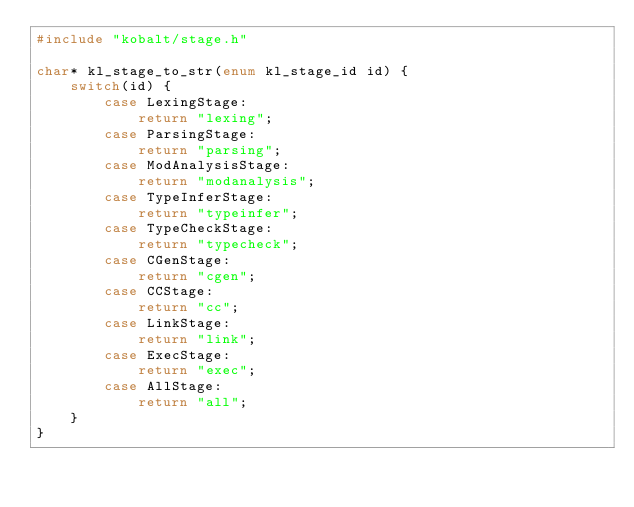Convert code to text. <code><loc_0><loc_0><loc_500><loc_500><_C_>#include "kobalt/stage.h"

char* kl_stage_to_str(enum kl_stage_id id) {
    switch(id) {
        case LexingStage:
            return "lexing";
        case ParsingStage:
            return "parsing";
        case ModAnalysisStage:
            return "modanalysis";
        case TypeInferStage:
            return "typeinfer";
        case TypeCheckStage:
            return "typecheck";
        case CGenStage:
            return "cgen";
        case CCStage:
            return "cc";
        case LinkStage:
            return "link";
        case ExecStage:
            return "exec";
        case AllStage:
            return "all";
    }
}
</code> 